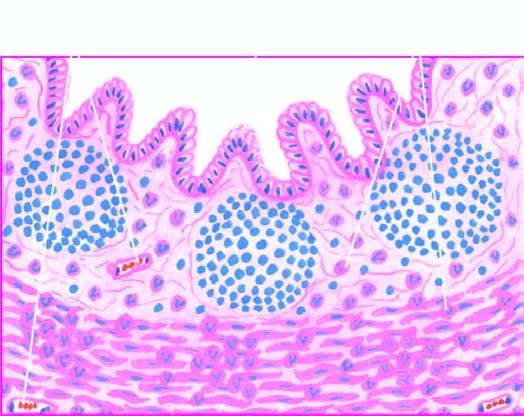what are necrosis of mucosa and periappendicitis?
Answer the question using a single word or phrase. Other changes present 